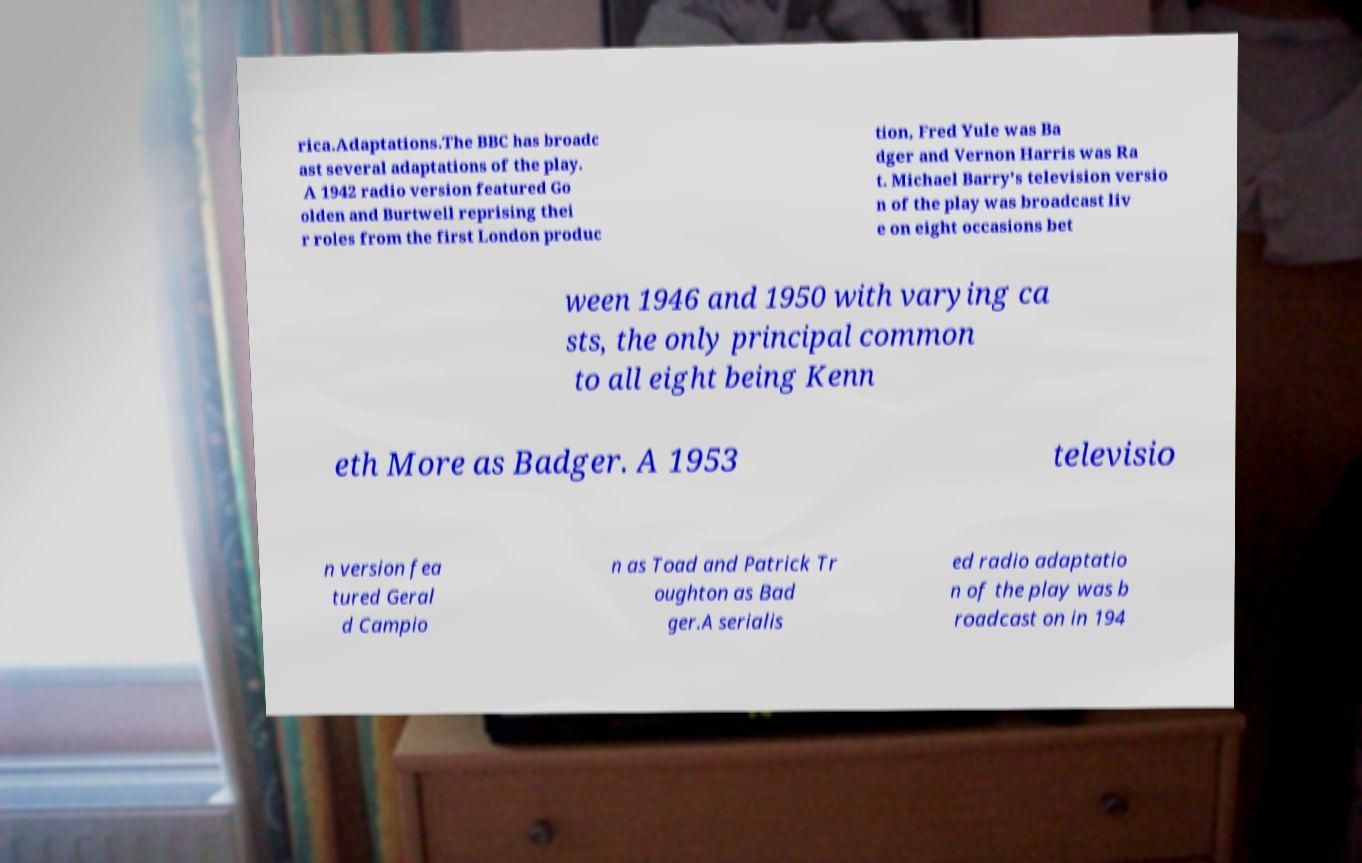There's text embedded in this image that I need extracted. Can you transcribe it verbatim? rica.Adaptations.The BBC has broadc ast several adaptations of the play. A 1942 radio version featured Go olden and Burtwell reprising thei r roles from the first London produc tion, Fred Yule was Ba dger and Vernon Harris was Ra t. Michael Barry's television versio n of the play was broadcast liv e on eight occasions bet ween 1946 and 1950 with varying ca sts, the only principal common to all eight being Kenn eth More as Badger. A 1953 televisio n version fea tured Geral d Campio n as Toad and Patrick Tr oughton as Bad ger.A serialis ed radio adaptatio n of the play was b roadcast on in 194 